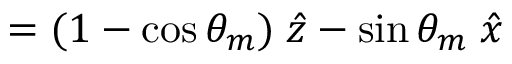<formula> <loc_0><loc_0><loc_500><loc_500>= ( 1 - \cos \theta _ { m } ) \, \hat { z } - \sin \theta _ { m } \, \hat { x }</formula> 